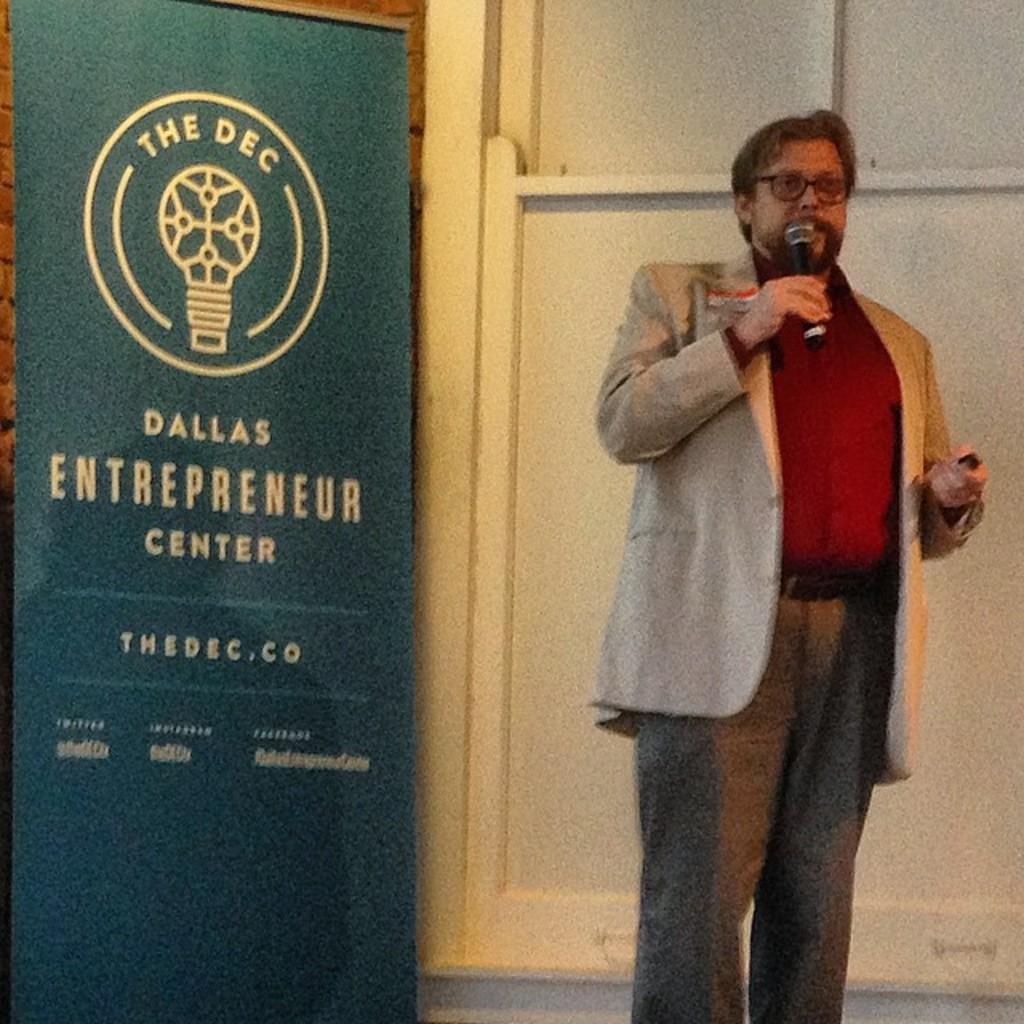What is the website?
Make the answer very short. Thedec.co. 